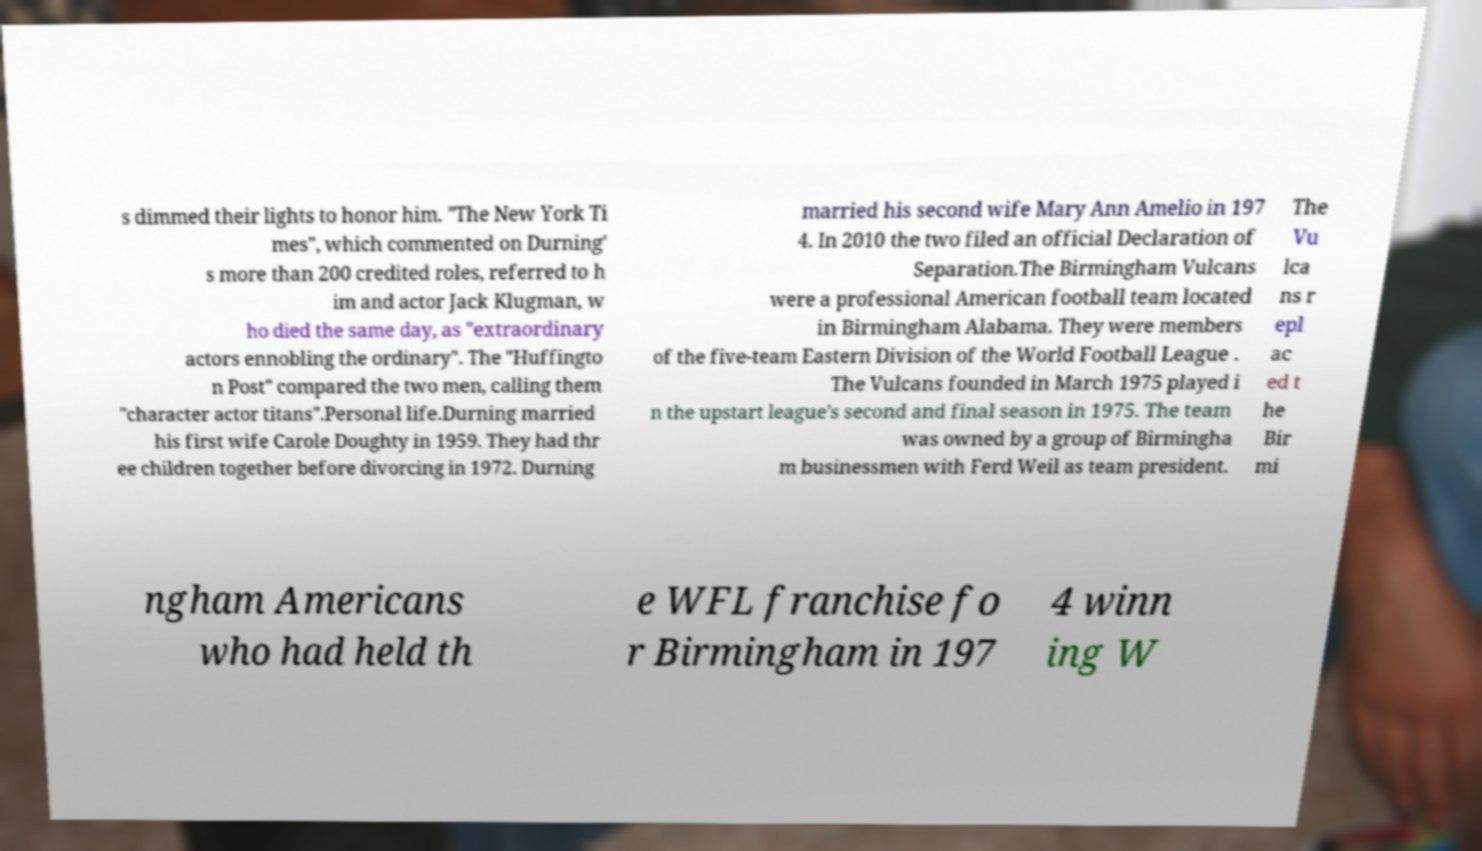Please identify and transcribe the text found in this image. s dimmed their lights to honor him. "The New York Ti mes", which commented on Durning' s more than 200 credited roles, referred to h im and actor Jack Klugman, w ho died the same day, as "extraordinary actors ennobling the ordinary". The "Huffingto n Post" compared the two men, calling them "character actor titans".Personal life.Durning married his first wife Carole Doughty in 1959. They had thr ee children together before divorcing in 1972. Durning married his second wife Mary Ann Amelio in 197 4. In 2010 the two filed an official Declaration of Separation.The Birmingham Vulcans were a professional American football team located in Birmingham Alabama. They were members of the five-team Eastern Division of the World Football League . The Vulcans founded in March 1975 played i n the upstart league's second and final season in 1975. The team was owned by a group of Birmingha m businessmen with Ferd Weil as team president. The Vu lca ns r epl ac ed t he Bir mi ngham Americans who had held th e WFL franchise fo r Birmingham in 197 4 winn ing W 